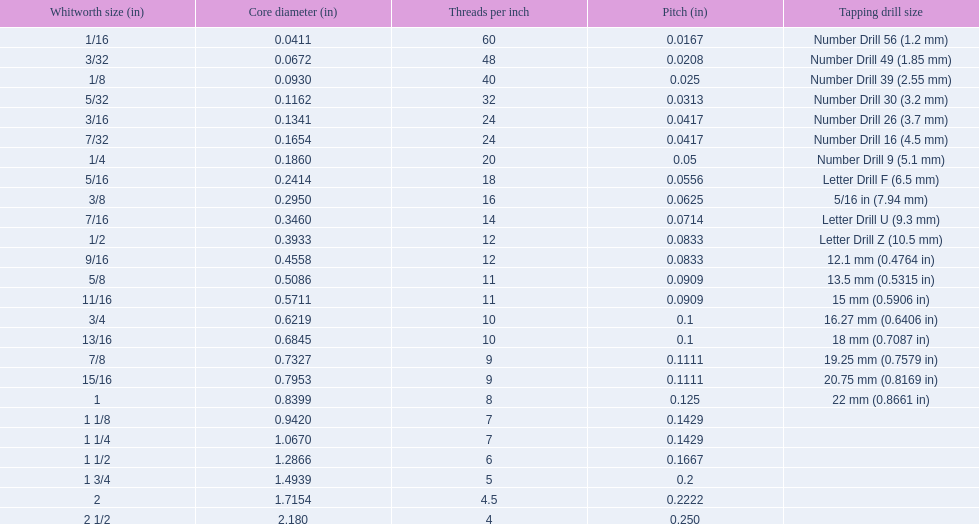What are the sizes of threads per inch? 60, 48, 40, 32, 24, 24, 20, 18, 16, 14, 12, 12, 11, 11, 10, 10, 9, 9, 8, 7, 7, 6, 5, 4.5, 4. Which whitworth size has only 5 threads per inch? 1 3/4. 